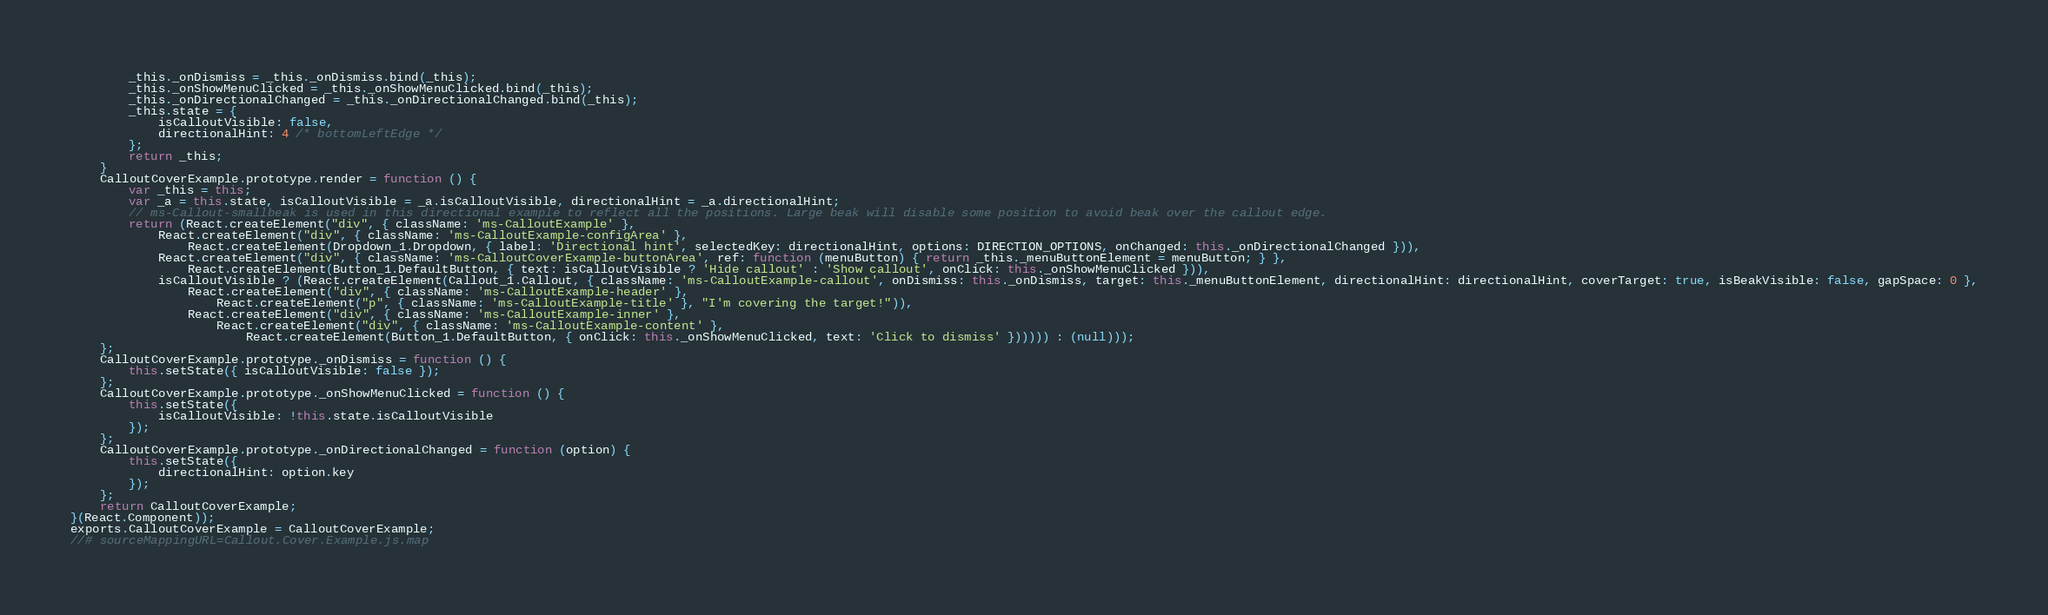<code> <loc_0><loc_0><loc_500><loc_500><_JavaScript_>        _this._onDismiss = _this._onDismiss.bind(_this);
        _this._onShowMenuClicked = _this._onShowMenuClicked.bind(_this);
        _this._onDirectionalChanged = _this._onDirectionalChanged.bind(_this);
        _this.state = {
            isCalloutVisible: false,
            directionalHint: 4 /* bottomLeftEdge */
        };
        return _this;
    }
    CalloutCoverExample.prototype.render = function () {
        var _this = this;
        var _a = this.state, isCalloutVisible = _a.isCalloutVisible, directionalHint = _a.directionalHint;
        // ms-Callout-smallbeak is used in this directional example to reflect all the positions. Large beak will disable some position to avoid beak over the callout edge.
        return (React.createElement("div", { className: 'ms-CalloutExample' },
            React.createElement("div", { className: 'ms-CalloutExample-configArea' },
                React.createElement(Dropdown_1.Dropdown, { label: 'Directional hint', selectedKey: directionalHint, options: DIRECTION_OPTIONS, onChanged: this._onDirectionalChanged })),
            React.createElement("div", { className: 'ms-CalloutCoverExample-buttonArea', ref: function (menuButton) { return _this._menuButtonElement = menuButton; } },
                React.createElement(Button_1.DefaultButton, { text: isCalloutVisible ? 'Hide callout' : 'Show callout', onClick: this._onShowMenuClicked })),
            isCalloutVisible ? (React.createElement(Callout_1.Callout, { className: 'ms-CalloutExample-callout', onDismiss: this._onDismiss, target: this._menuButtonElement, directionalHint: directionalHint, coverTarget: true, isBeakVisible: false, gapSpace: 0 },
                React.createElement("div", { className: 'ms-CalloutExample-header' },
                    React.createElement("p", { className: 'ms-CalloutExample-title' }, "I'm covering the target!")),
                React.createElement("div", { className: 'ms-CalloutExample-inner' },
                    React.createElement("div", { className: 'ms-CalloutExample-content' },
                        React.createElement(Button_1.DefaultButton, { onClick: this._onShowMenuClicked, text: 'Click to dismiss' }))))) : (null)));
    };
    CalloutCoverExample.prototype._onDismiss = function () {
        this.setState({ isCalloutVisible: false });
    };
    CalloutCoverExample.prototype._onShowMenuClicked = function () {
        this.setState({
            isCalloutVisible: !this.state.isCalloutVisible
        });
    };
    CalloutCoverExample.prototype._onDirectionalChanged = function (option) {
        this.setState({
            directionalHint: option.key
        });
    };
    return CalloutCoverExample;
}(React.Component));
exports.CalloutCoverExample = CalloutCoverExample;
//# sourceMappingURL=Callout.Cover.Example.js.map</code> 